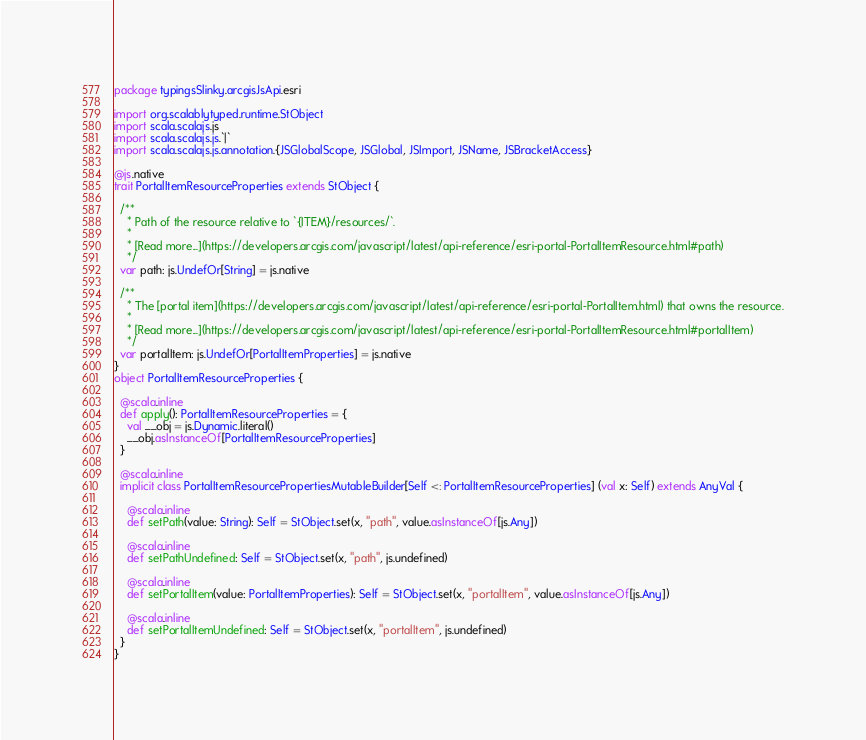Convert code to text. <code><loc_0><loc_0><loc_500><loc_500><_Scala_>package typingsSlinky.arcgisJsApi.esri

import org.scalablytyped.runtime.StObject
import scala.scalajs.js
import scala.scalajs.js.`|`
import scala.scalajs.js.annotation.{JSGlobalScope, JSGlobal, JSImport, JSName, JSBracketAccess}

@js.native
trait PortalItemResourceProperties extends StObject {
  
  /**
    * Path of the resource relative to `{ITEM}/resources/`.
    *
    * [Read more...](https://developers.arcgis.com/javascript/latest/api-reference/esri-portal-PortalItemResource.html#path)
    */
  var path: js.UndefOr[String] = js.native
  
  /**
    * The [portal item](https://developers.arcgis.com/javascript/latest/api-reference/esri-portal-PortalItem.html) that owns the resource.
    *
    * [Read more...](https://developers.arcgis.com/javascript/latest/api-reference/esri-portal-PortalItemResource.html#portalItem)
    */
  var portalItem: js.UndefOr[PortalItemProperties] = js.native
}
object PortalItemResourceProperties {
  
  @scala.inline
  def apply(): PortalItemResourceProperties = {
    val __obj = js.Dynamic.literal()
    __obj.asInstanceOf[PortalItemResourceProperties]
  }
  
  @scala.inline
  implicit class PortalItemResourcePropertiesMutableBuilder[Self <: PortalItemResourceProperties] (val x: Self) extends AnyVal {
    
    @scala.inline
    def setPath(value: String): Self = StObject.set(x, "path", value.asInstanceOf[js.Any])
    
    @scala.inline
    def setPathUndefined: Self = StObject.set(x, "path", js.undefined)
    
    @scala.inline
    def setPortalItem(value: PortalItemProperties): Self = StObject.set(x, "portalItem", value.asInstanceOf[js.Any])
    
    @scala.inline
    def setPortalItemUndefined: Self = StObject.set(x, "portalItem", js.undefined)
  }
}
</code> 